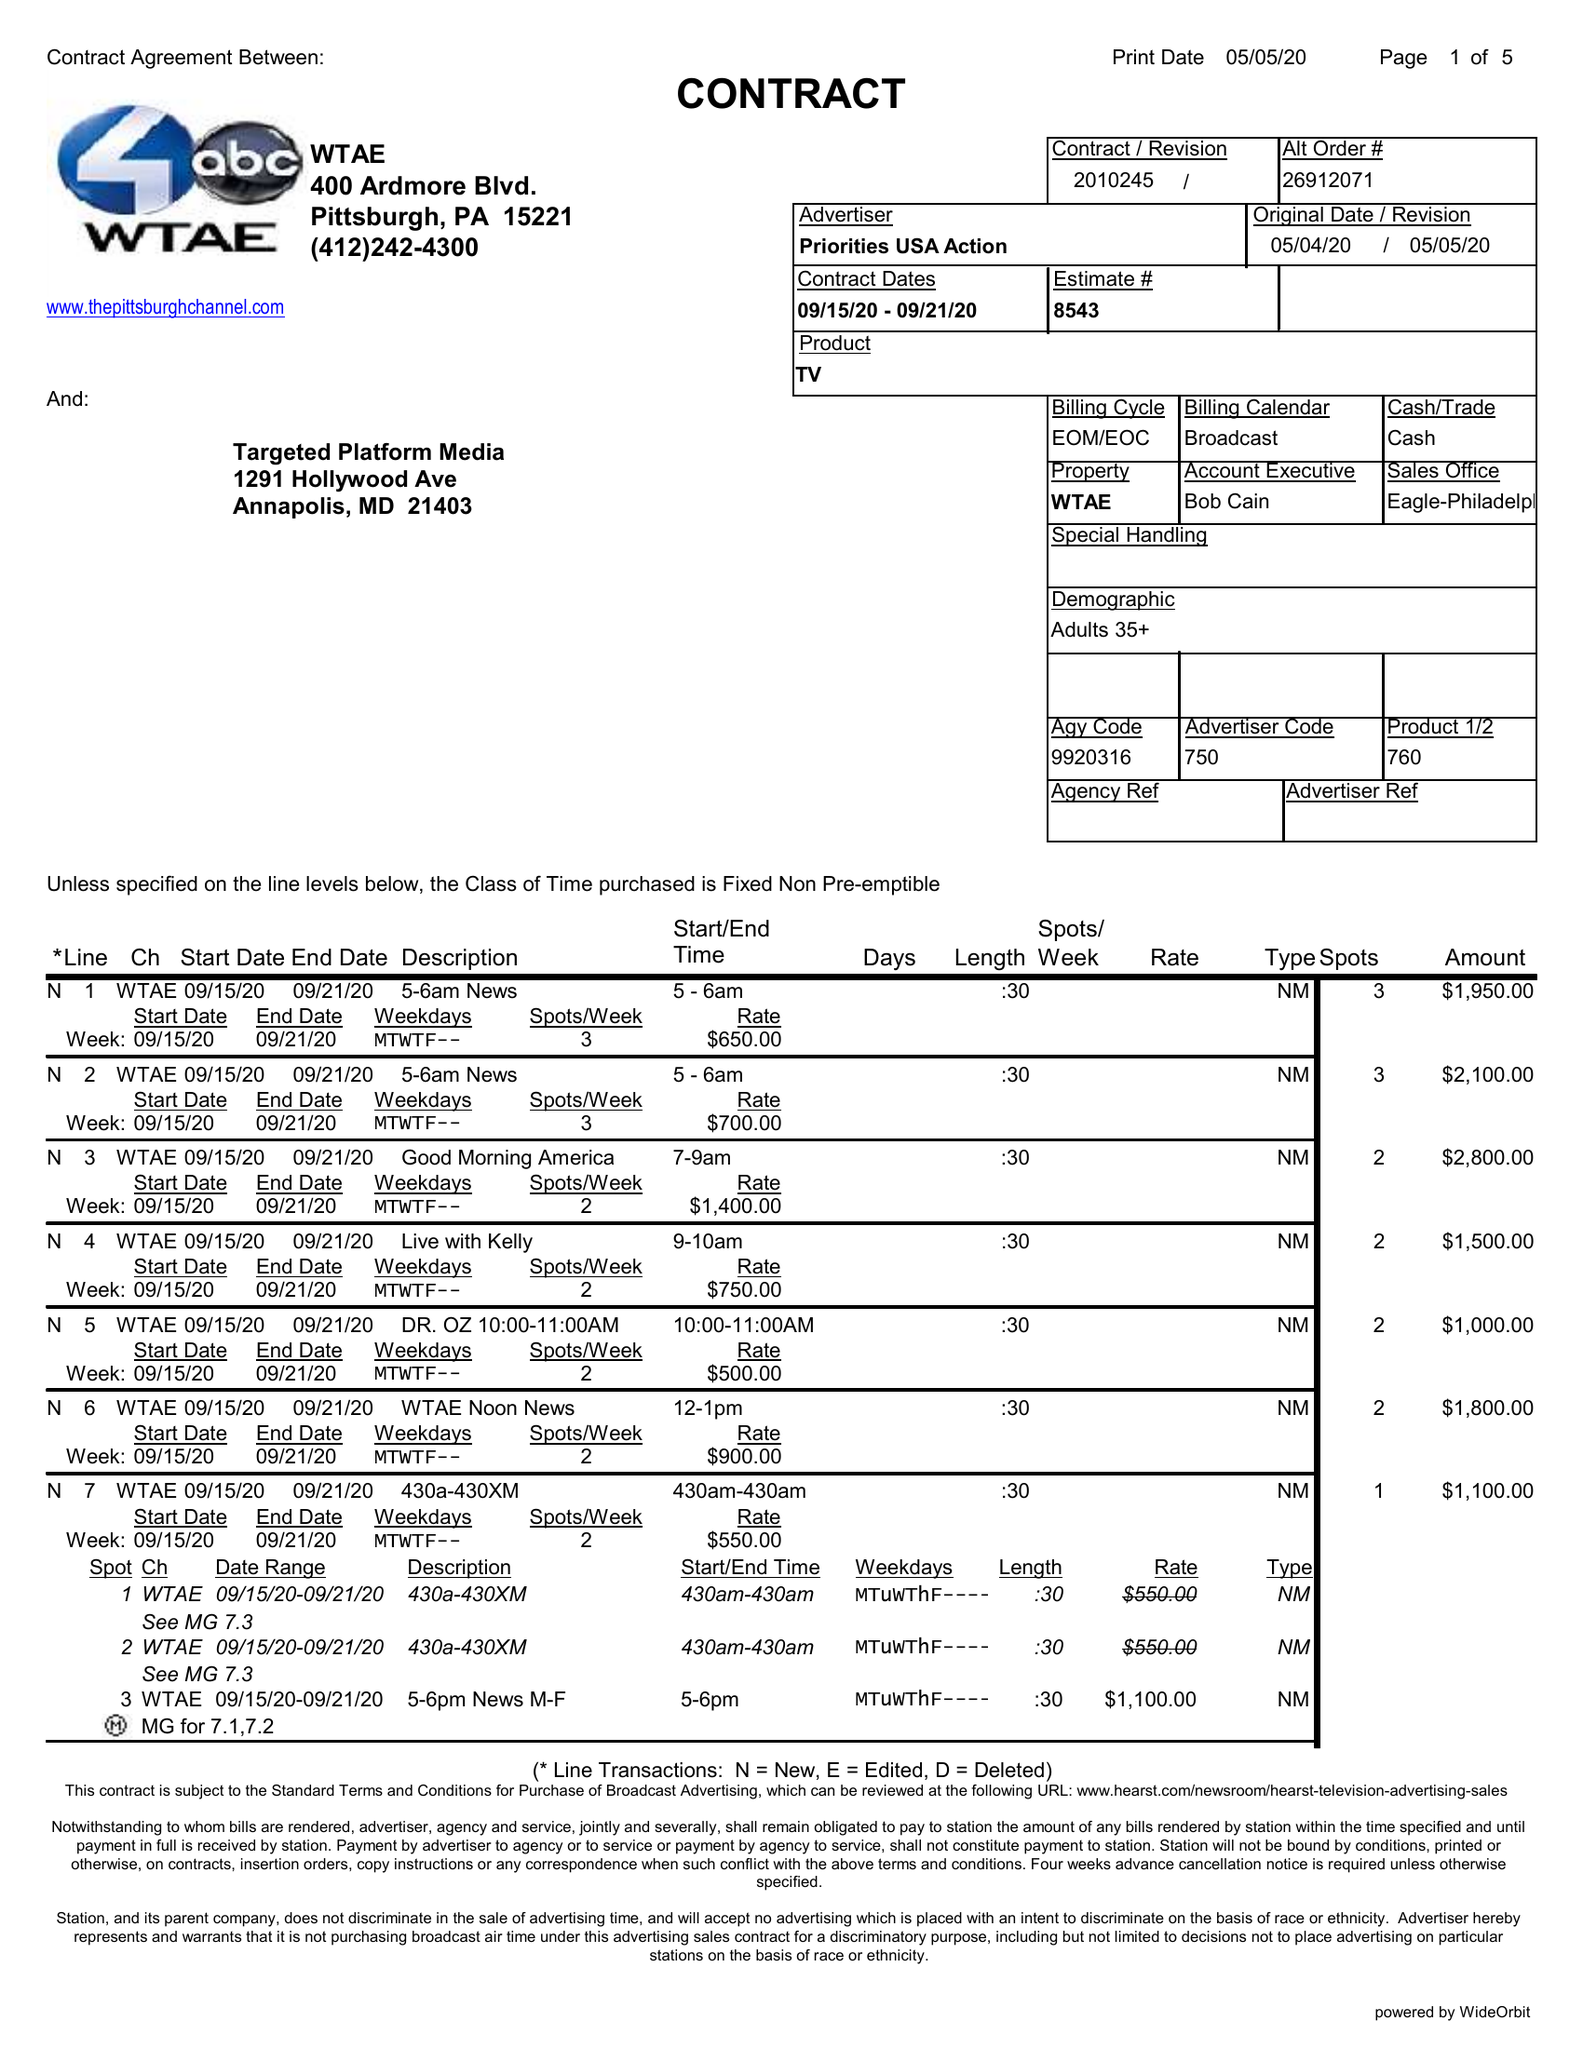What is the value for the advertiser?
Answer the question using a single word or phrase. PRIORITIES USA ACTION 